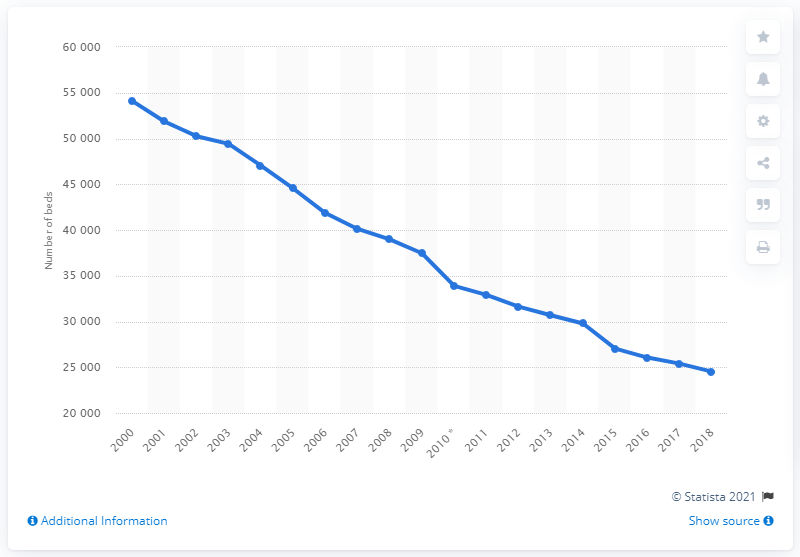Draw attention to some important aspects in this diagram. In 2018, there were 24,523 psychiatric care beds available in the United Kingdom. Since the year 2000, there has been a gradual decrease in the number of psychiatric beds available in the United Kingdom. 